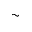Convert formula to latex. <formula><loc_0><loc_0><loc_500><loc_500>\sim</formula> 